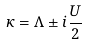Convert formula to latex. <formula><loc_0><loc_0><loc_500><loc_500>\kappa = \Lambda \pm i \frac { U } { 2 }</formula> 